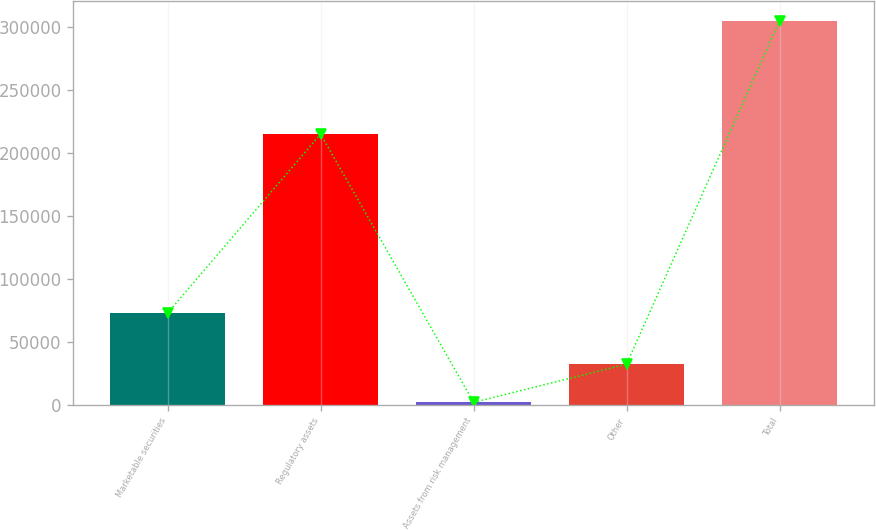<chart> <loc_0><loc_0><loc_500><loc_500><bar_chart><fcel>Marketable securities<fcel>Regulatory assets<fcel>Assets from risk management<fcel>Other<fcel>Total<nl><fcel>72701<fcel>214890<fcel>1822<fcel>32141.7<fcel>305019<nl></chart> 